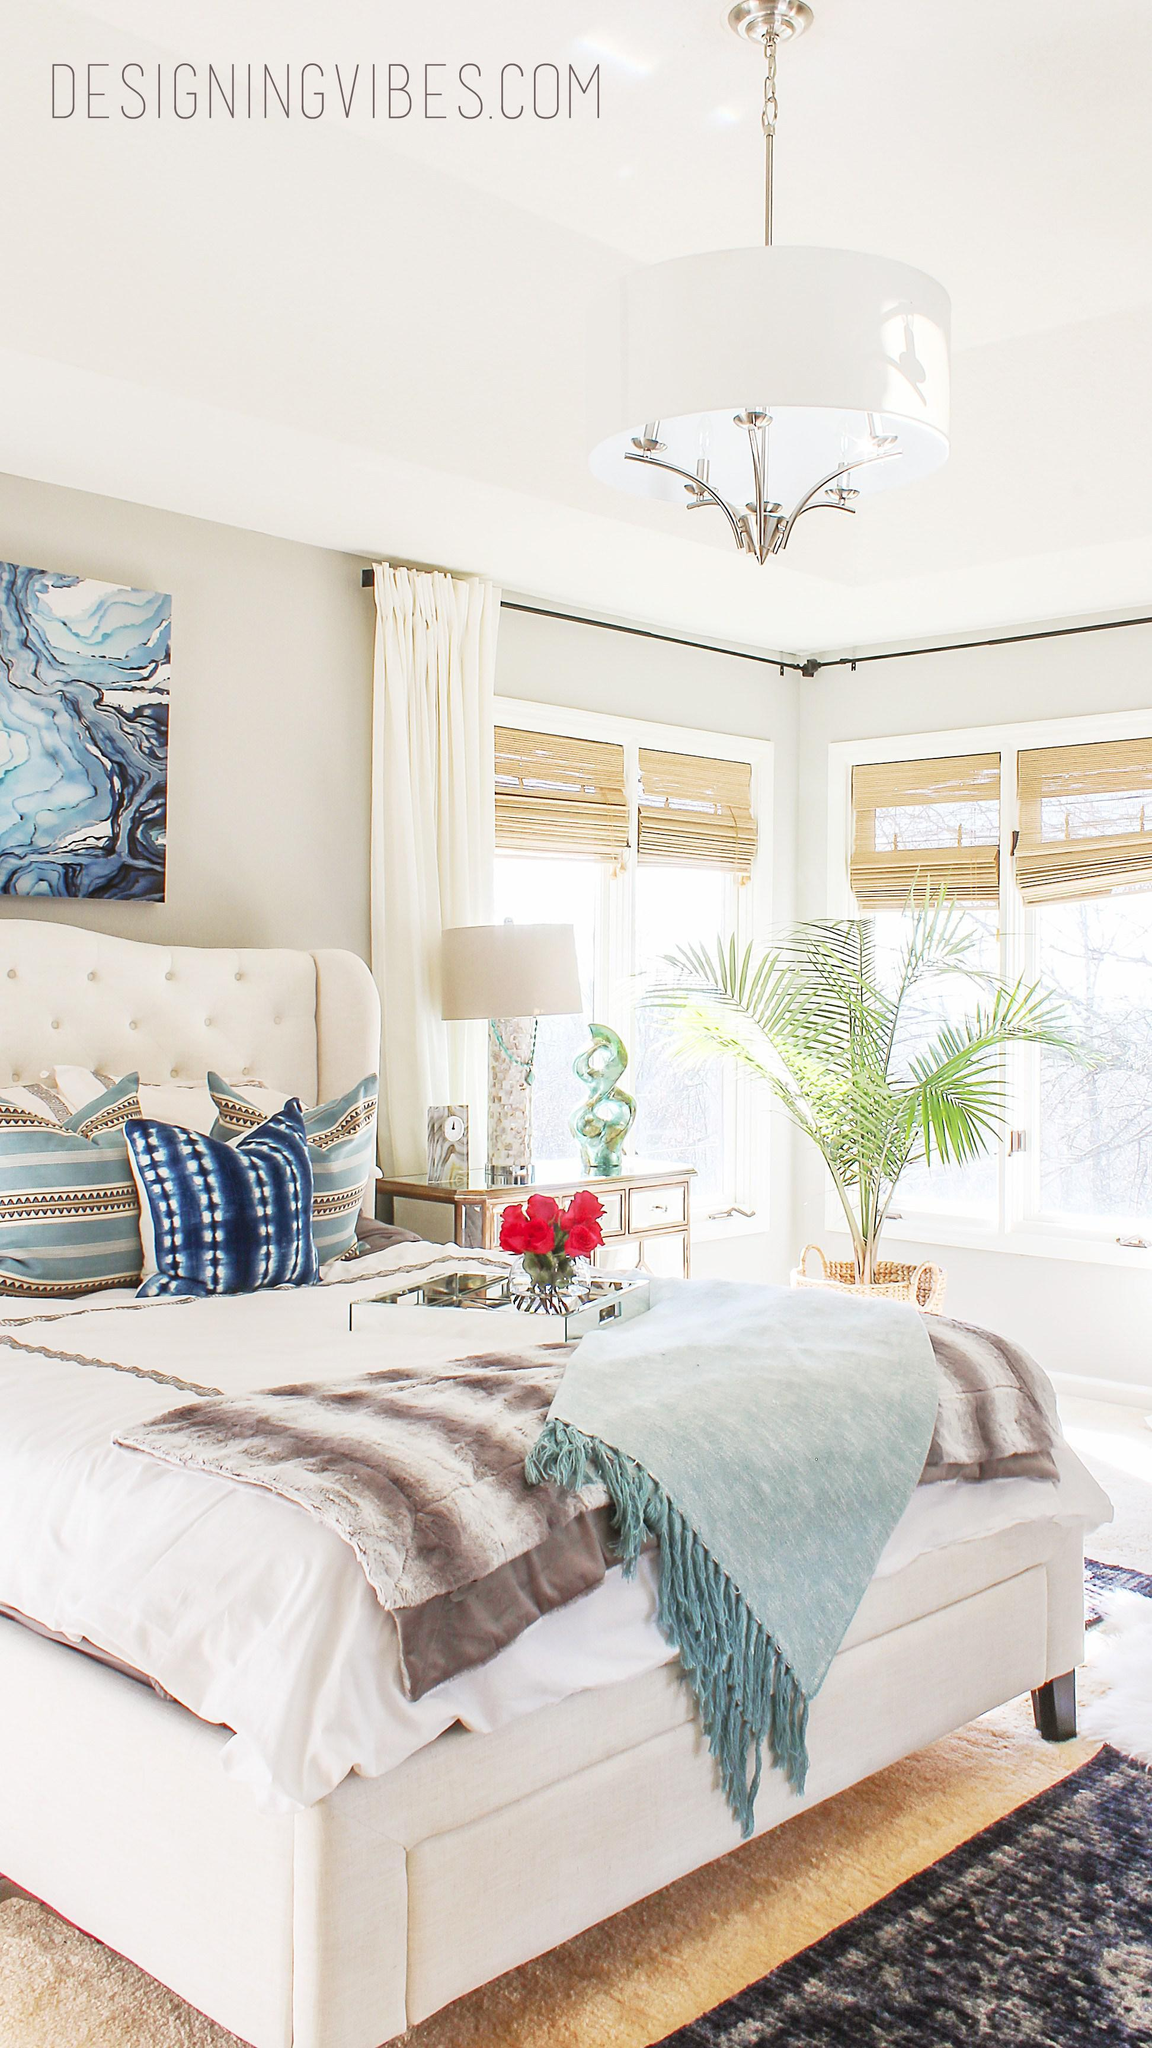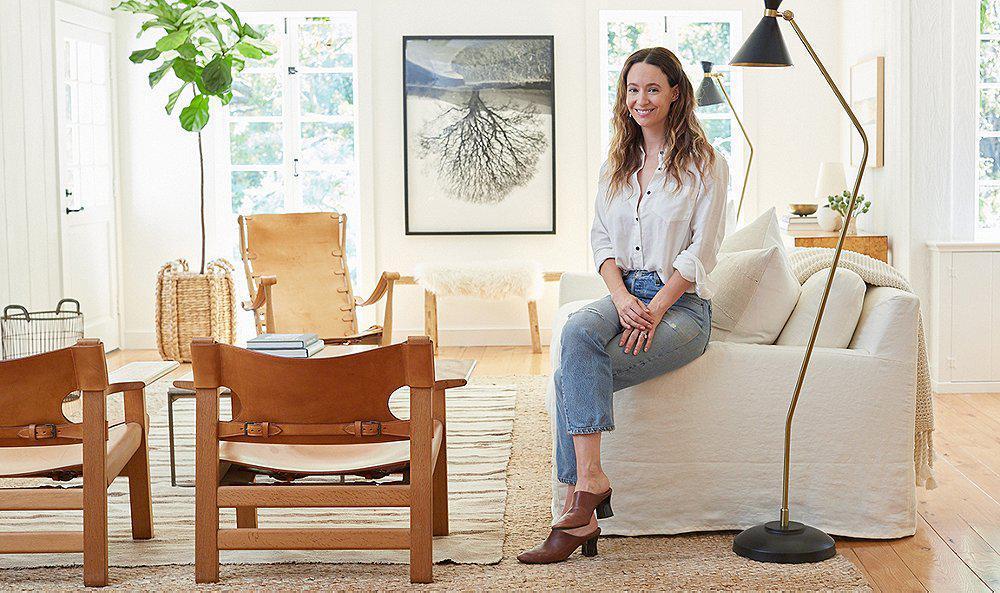The first image is the image on the left, the second image is the image on the right. For the images shown, is this caption "There is a person sitting on a couch." true? Answer yes or no. Yes. The first image is the image on the left, the second image is the image on the right. Assess this claim about the two images: "An image contains a person sitting on a couch.". Correct or not? Answer yes or no. Yes. 